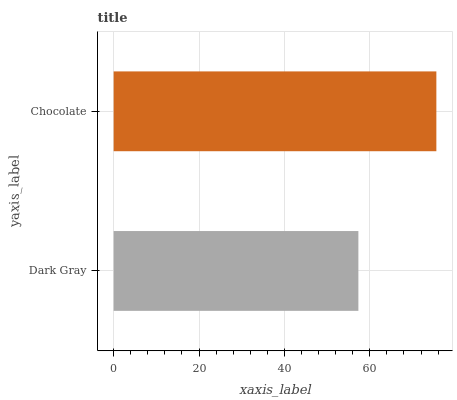Is Dark Gray the minimum?
Answer yes or no. Yes. Is Chocolate the maximum?
Answer yes or no. Yes. Is Chocolate the minimum?
Answer yes or no. No. Is Chocolate greater than Dark Gray?
Answer yes or no. Yes. Is Dark Gray less than Chocolate?
Answer yes or no. Yes. Is Dark Gray greater than Chocolate?
Answer yes or no. No. Is Chocolate less than Dark Gray?
Answer yes or no. No. Is Chocolate the high median?
Answer yes or no. Yes. Is Dark Gray the low median?
Answer yes or no. Yes. Is Dark Gray the high median?
Answer yes or no. No. Is Chocolate the low median?
Answer yes or no. No. 